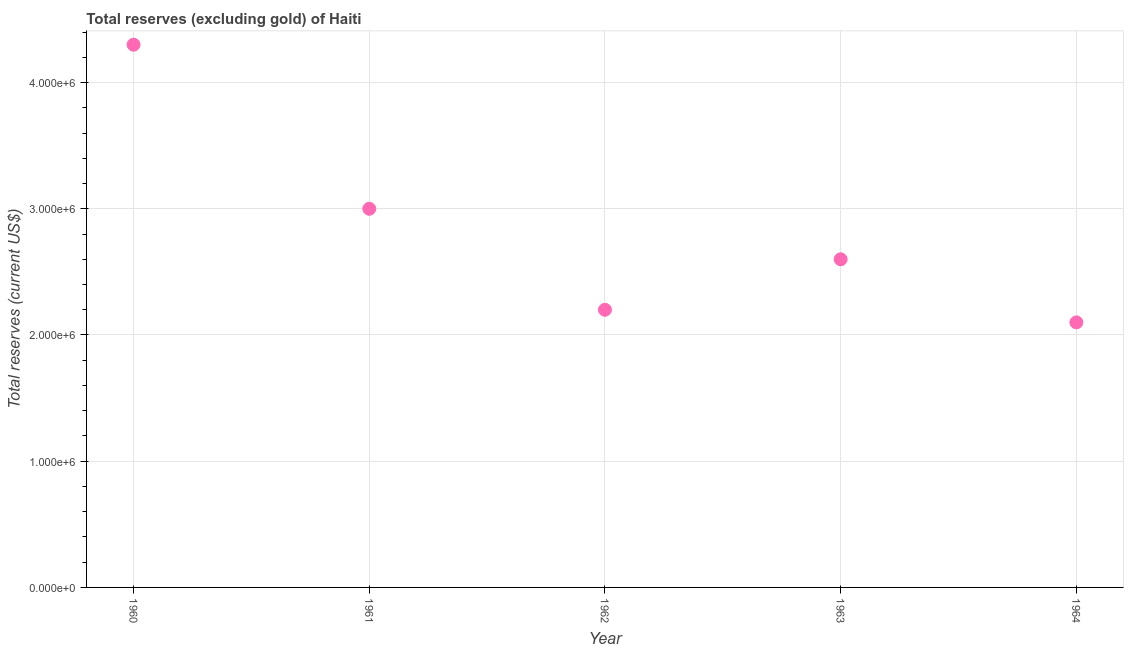Across all years, what is the maximum total reserves (excluding gold)?
Provide a short and direct response. 4.30e+06. Across all years, what is the minimum total reserves (excluding gold)?
Make the answer very short. 2.10e+06. In which year was the total reserves (excluding gold) maximum?
Provide a short and direct response. 1960. In which year was the total reserves (excluding gold) minimum?
Your answer should be very brief. 1964. What is the sum of the total reserves (excluding gold)?
Ensure brevity in your answer.  1.42e+07. What is the difference between the total reserves (excluding gold) in 1960 and 1962?
Your response must be concise. 2.10e+06. What is the average total reserves (excluding gold) per year?
Your answer should be very brief. 2.84e+06. What is the median total reserves (excluding gold)?
Your response must be concise. 2.60e+06. Do a majority of the years between 1964 and 1961 (inclusive) have total reserves (excluding gold) greater than 400000 US$?
Your answer should be very brief. Yes. What is the ratio of the total reserves (excluding gold) in 1960 to that in 1962?
Keep it short and to the point. 1.95. Is the total reserves (excluding gold) in 1960 less than that in 1963?
Provide a succinct answer. No. What is the difference between the highest and the second highest total reserves (excluding gold)?
Offer a very short reply. 1.30e+06. What is the difference between the highest and the lowest total reserves (excluding gold)?
Your answer should be very brief. 2.20e+06. In how many years, is the total reserves (excluding gold) greater than the average total reserves (excluding gold) taken over all years?
Your response must be concise. 2. Does the total reserves (excluding gold) monotonically increase over the years?
Provide a succinct answer. No. Does the graph contain any zero values?
Your answer should be very brief. No. Does the graph contain grids?
Offer a very short reply. Yes. What is the title of the graph?
Keep it short and to the point. Total reserves (excluding gold) of Haiti. What is the label or title of the Y-axis?
Your answer should be very brief. Total reserves (current US$). What is the Total reserves (current US$) in 1960?
Offer a terse response. 4.30e+06. What is the Total reserves (current US$) in 1962?
Your answer should be very brief. 2.20e+06. What is the Total reserves (current US$) in 1963?
Your answer should be very brief. 2.60e+06. What is the Total reserves (current US$) in 1964?
Offer a very short reply. 2.10e+06. What is the difference between the Total reserves (current US$) in 1960 and 1961?
Offer a very short reply. 1.30e+06. What is the difference between the Total reserves (current US$) in 1960 and 1962?
Make the answer very short. 2.10e+06. What is the difference between the Total reserves (current US$) in 1960 and 1963?
Keep it short and to the point. 1.70e+06. What is the difference between the Total reserves (current US$) in 1960 and 1964?
Your response must be concise. 2.20e+06. What is the difference between the Total reserves (current US$) in 1961 and 1962?
Your response must be concise. 8.00e+05. What is the difference between the Total reserves (current US$) in 1961 and 1964?
Offer a terse response. 9.00e+05. What is the difference between the Total reserves (current US$) in 1962 and 1963?
Offer a terse response. -4.00e+05. What is the difference between the Total reserves (current US$) in 1962 and 1964?
Keep it short and to the point. 1.00e+05. What is the ratio of the Total reserves (current US$) in 1960 to that in 1961?
Offer a very short reply. 1.43. What is the ratio of the Total reserves (current US$) in 1960 to that in 1962?
Keep it short and to the point. 1.96. What is the ratio of the Total reserves (current US$) in 1960 to that in 1963?
Provide a succinct answer. 1.65. What is the ratio of the Total reserves (current US$) in 1960 to that in 1964?
Provide a short and direct response. 2.05. What is the ratio of the Total reserves (current US$) in 1961 to that in 1962?
Keep it short and to the point. 1.36. What is the ratio of the Total reserves (current US$) in 1961 to that in 1963?
Keep it short and to the point. 1.15. What is the ratio of the Total reserves (current US$) in 1961 to that in 1964?
Make the answer very short. 1.43. What is the ratio of the Total reserves (current US$) in 1962 to that in 1963?
Your answer should be compact. 0.85. What is the ratio of the Total reserves (current US$) in 1962 to that in 1964?
Your answer should be compact. 1.05. What is the ratio of the Total reserves (current US$) in 1963 to that in 1964?
Make the answer very short. 1.24. 